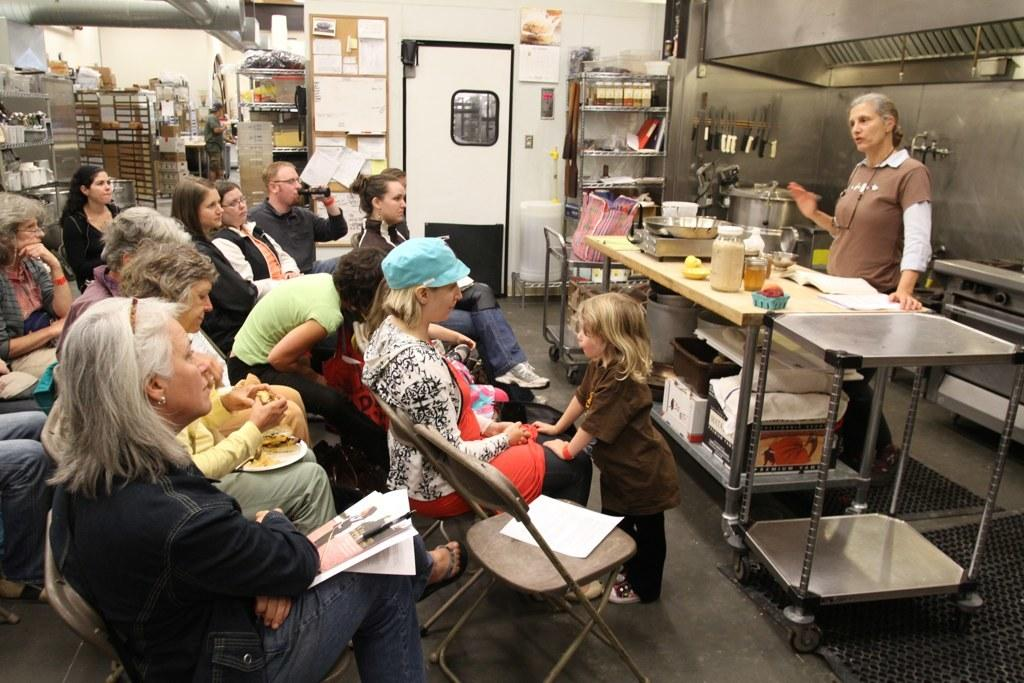Who is the main subject in the image? There is a woman in the image. What is the woman doing in the image? The woman is standing and speaking. Can you describe the other people in the image? There is a group of people in the image, and they are sitting on chairs. What type of religious selection is being made in the image? There is no religious selection or any religious context present in the image. 